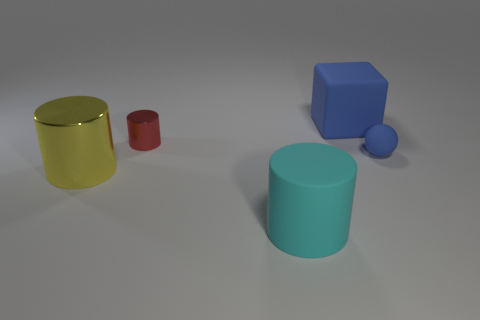Subtract all cyan matte cylinders. How many cylinders are left? 2 Add 5 small cyan rubber cubes. How many objects exist? 10 Subtract all red cylinders. How many cylinders are left? 2 Subtract all spheres. How many objects are left? 4 Add 3 tiny matte spheres. How many tiny matte spheres are left? 4 Add 5 tiny purple cubes. How many tiny purple cubes exist? 5 Subtract 1 red cylinders. How many objects are left? 4 Subtract all gray balls. Subtract all gray blocks. How many balls are left? 1 Subtract all small green rubber objects. Subtract all large cyan cylinders. How many objects are left? 4 